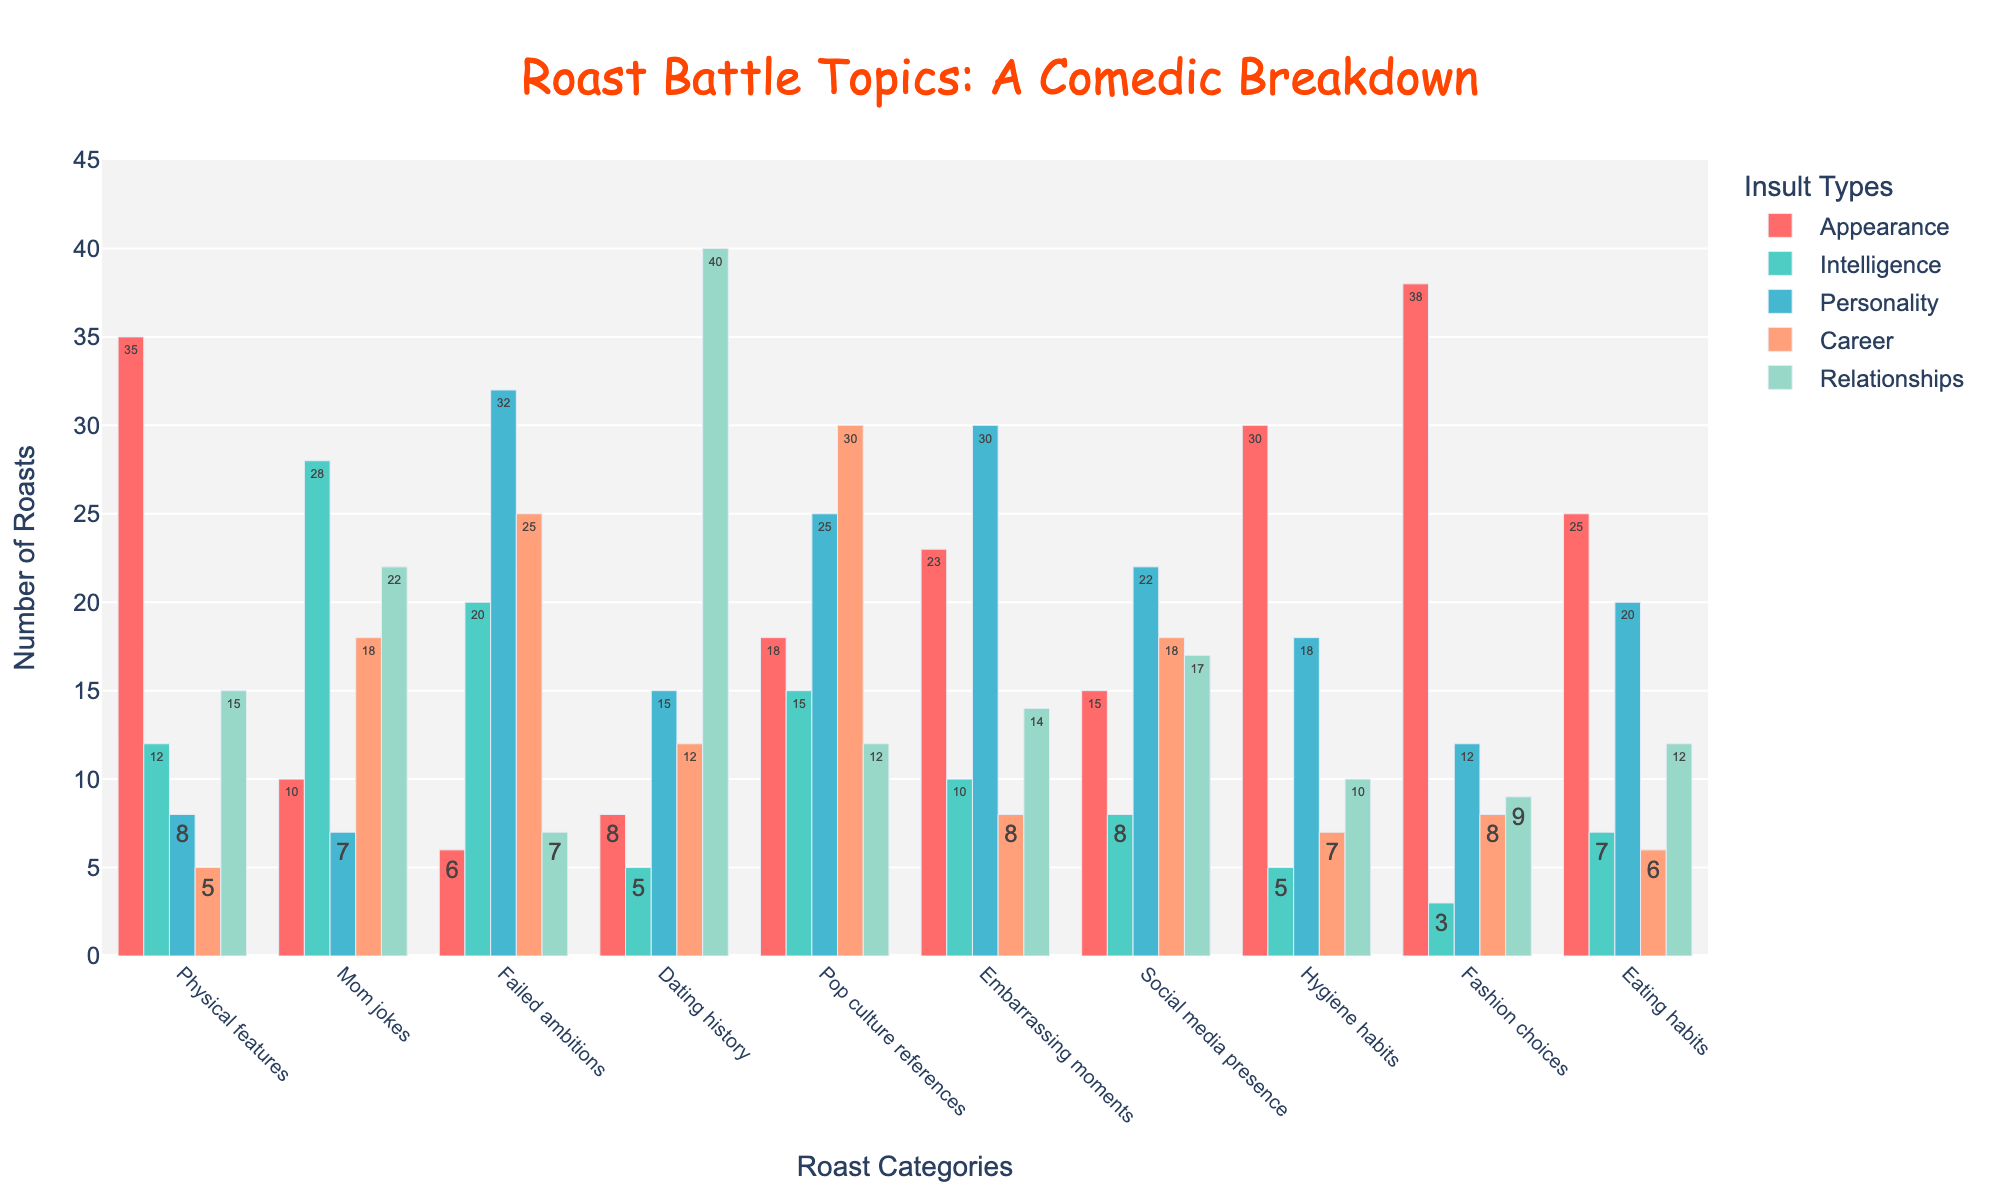Which roast category has the highest number of insults related to intelligence? By examining the bar heights for the insult type "Intelligence" across all roast categories, we see that "Mom jokes" has the tallest bar, indicating it has the highest count of intelligence-related insults.
Answer: Mom jokes Which insult type has the lowest count for the category "Eating habits"? Looking at the "Eating habits" bar section for each insult type, the shortest bar corresponds to "Intelligence."
Answer: Intelligence What is the total number of roasts for "Physical features" across all insult types? Add up the counts for "Physical features" in each insult type: 35 (Appearance) + 12 (Intelligence) + 8 (Personality) + 5 (Career) + 15 (Relationships) = 75.
Answer: 75 Which category has a higher count for "Appearance": "Fashion choices" or "Hygiene habits"? Comparing the heights of the bars in the "Appearance" section, "Fashion choices" has a higher count (38) than "Hygiene habits" (30).
Answer: Fashion choices How much more is the count for "Pop culture references" than "Embarrassing moments" in the "Career" insult type? Subtract the count for "Embarrassing moments" (8) from "Pop culture references" (30) in the "Career" section: 30 - 8 = 22.
Answer: 22 Which insult type is most frequent in the "Dating history" category? By observing the bar heights in the "Dating history" section, the tallest bar represents "Relationships" with a count of 40.
Answer: Relationships Compare the count for "Hygiene habits" in the "Personality" insult type with the count for "Embarrassing moments" in the same type. Which is higher? Checking the heights of the bars for "Personality," "Embarrassing moments" has a count of 30, while "Hygiene habits" has a count of 18, making "Embarrassing moments" higher.
Answer: Embarrassing moments In terms of "Appearance" insults, what is the combined count for "Mom jokes" and "Pop culture references"? Add the counts for "Appearance" in both categories: 10 (Mom jokes) + 18 (Pop culture references) = 28.
Answer: 28 What is the difference in the count of "Personality" insults between "Failed ambitions" and "Social media presence"? Subtract the count of "Personality" insults for "Social media presence" (22) from "Failed ambitions" (32): 32 - 22 = 10.
Answer: 10 Which insult type has the highest average count across all roast categories? Calculate the average for each insult type and compare:
- Appearance: (35 + 10 + 6 + 8 + 18 + 23 + 15 + 30 + 38 + 25) / 10 = 20.8
- Intelligence: (12 + 28 + 20 + 5 + 15 + 10 + 8 + 5 + 3 + 7) / 10 = 11.3
- Personality: (8 + 7 + 32 + 15 + 25 + 30 + 22 + 18 + 12 + 20) / 10 = 18.9
- Career: (5 + 18 + 25 + 12 + 30 + 8 + 18 + 7 + 8 + 6) / 10 = 13.7
- Relationships: (15 + 22 + 7 + 40 + 12 + 14 + 17 + 10 + 9 + 12) / 10 = 15.8
Hence, "Appearance" has the highest average count.
Answer: Appearance 